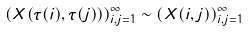Convert formula to latex. <formula><loc_0><loc_0><loc_500><loc_500>\left ( X ( \tau ( i ) , \tau ( j ) ) \right ) _ { i , j = 1 } ^ { \infty } \sim \left ( X ( i , j ) \right ) _ { i , j = 1 } ^ { \infty }</formula> 